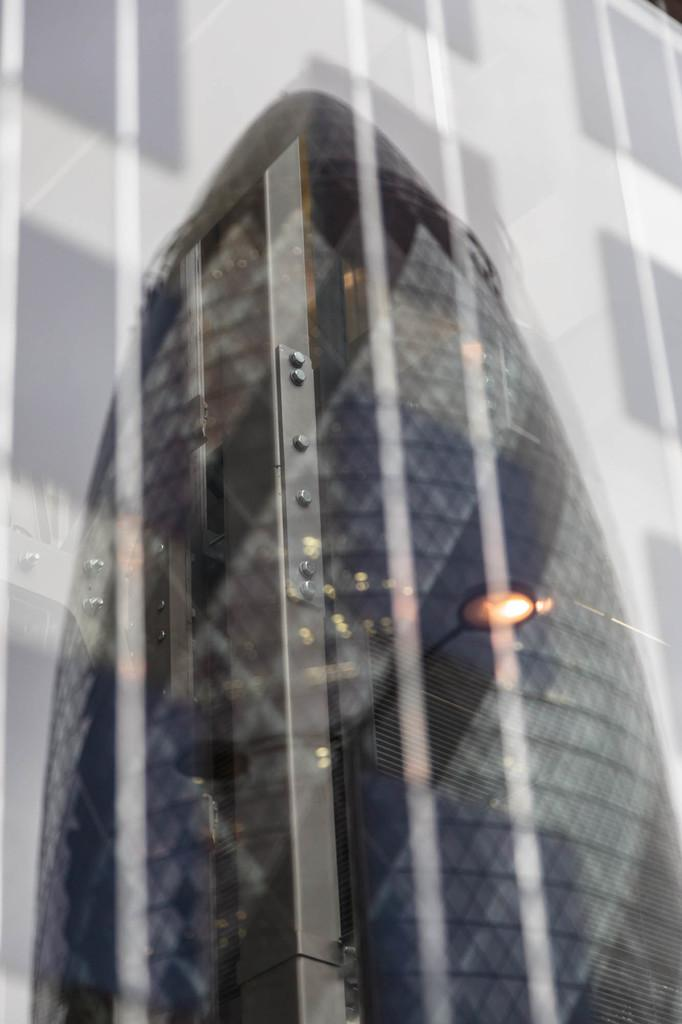What type of material is present in the image? There is a glass material in the image. What can be seen reflected in the glass material? The glass material has a reflection of a tower. What type of structure is visible in the image? There is a building visible in the image. What type of popcorn is being used to decorate the building in the image? There is no popcorn present in the image, and therefore no such decoration can be observed. 